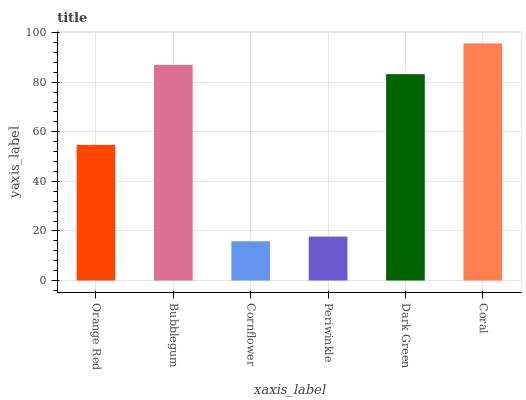Is Cornflower the minimum?
Answer yes or no. Yes. Is Coral the maximum?
Answer yes or no. Yes. Is Bubblegum the minimum?
Answer yes or no. No. Is Bubblegum the maximum?
Answer yes or no. No. Is Bubblegum greater than Orange Red?
Answer yes or no. Yes. Is Orange Red less than Bubblegum?
Answer yes or no. Yes. Is Orange Red greater than Bubblegum?
Answer yes or no. No. Is Bubblegum less than Orange Red?
Answer yes or no. No. Is Dark Green the high median?
Answer yes or no. Yes. Is Orange Red the low median?
Answer yes or no. Yes. Is Coral the high median?
Answer yes or no. No. Is Cornflower the low median?
Answer yes or no. No. 